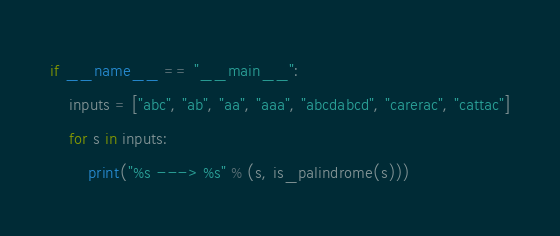<code> <loc_0><loc_0><loc_500><loc_500><_Python_>
if __name__ == "__main__":
    inputs = ["abc", "ab", "aa", "aaa", "abcdabcd", "carerac", "cattac"]
    for s in inputs:
        print("%s ---> %s" % (s, is_palindrome(s)))

</code> 